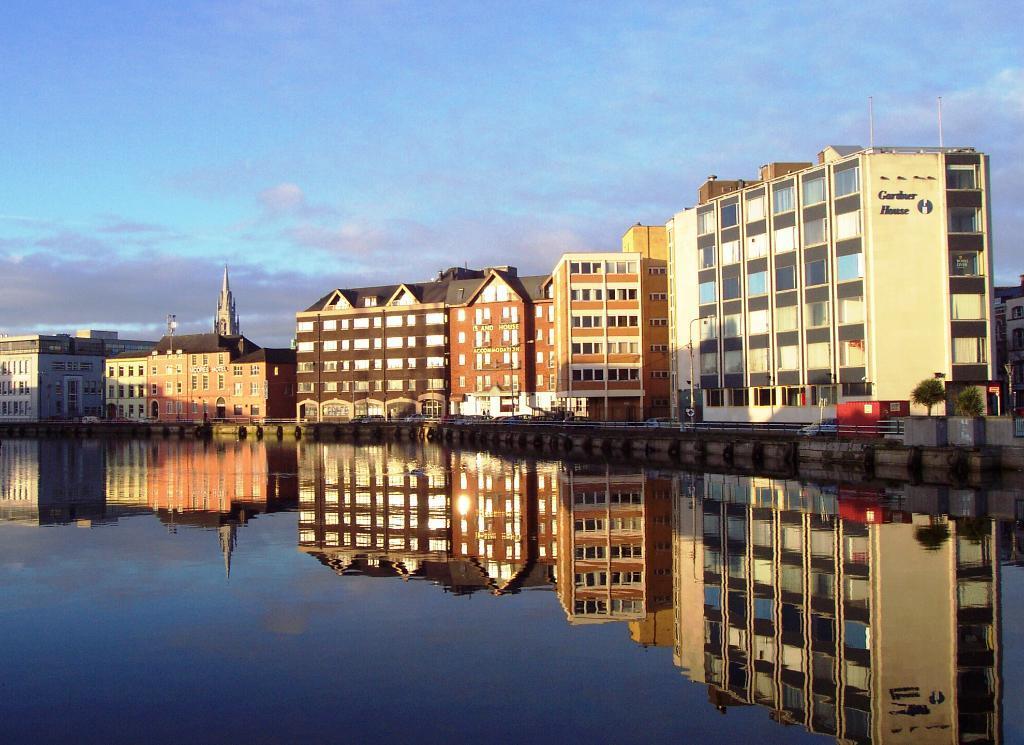In one or two sentences, can you explain what this image depicts? Here we can see water and in this water we can see reflection of buildings. In the background we can see buildings,plants and sky. 